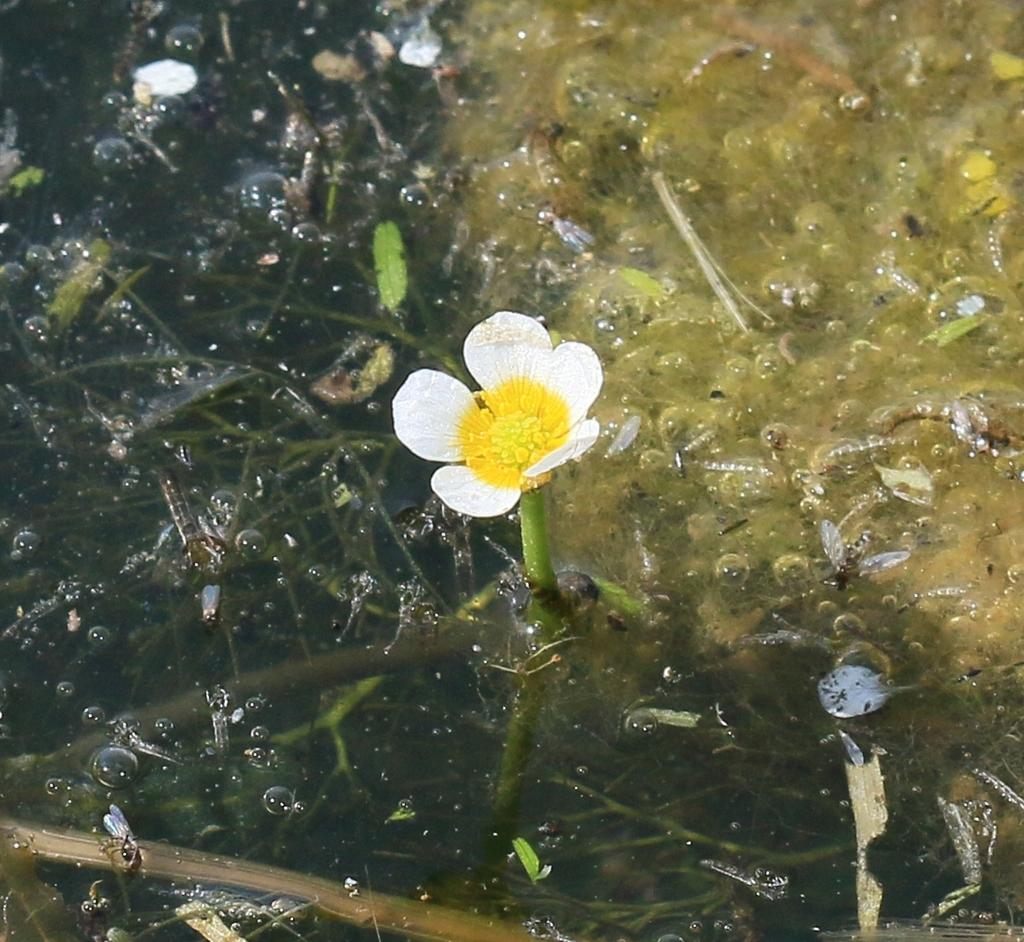What is attached to the stem in the image? There is a flower attached to the stem in the image. How is the stem positioned in the image? The stem is in the water. What other living organisms can be seen in the image? Insects are visible in the image. What is the condition of the water in the image? Water bubbles are present in the image. Are there any other stems visible in the image? Yes, there are stems in the water. What type of vegetation is visible in the water? Grass is visible in the water. What type of tooth can be seen in the image? There is no tooth present in the image. Is there any poison visible in the image? There is no poison present in the image. 